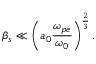Convert formula to latex. <formula><loc_0><loc_0><loc_500><loc_500>\beta _ { s } \ll \left ( a _ { 0 } \frac { \omega _ { p e } } { \omega _ { 0 } } \right ) ^ { \frac { 2 } { 3 } } .</formula> 